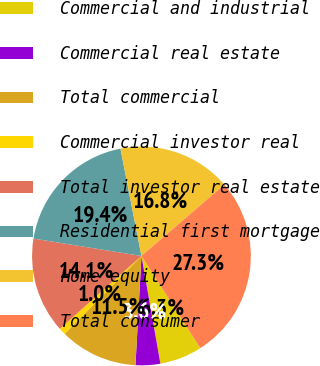Convert chart to OTSL. <chart><loc_0><loc_0><loc_500><loc_500><pie_chart><fcel>Commercial and industrial<fcel>Commercial real estate<fcel>Total commercial<fcel>Commercial investor real<fcel>Total investor real estate<fcel>Residential first mortgage<fcel>Home equity<fcel>Total consumer<nl><fcel>6.27%<fcel>3.64%<fcel>11.52%<fcel>1.02%<fcel>14.14%<fcel>19.39%<fcel>16.77%<fcel>27.27%<nl></chart> 